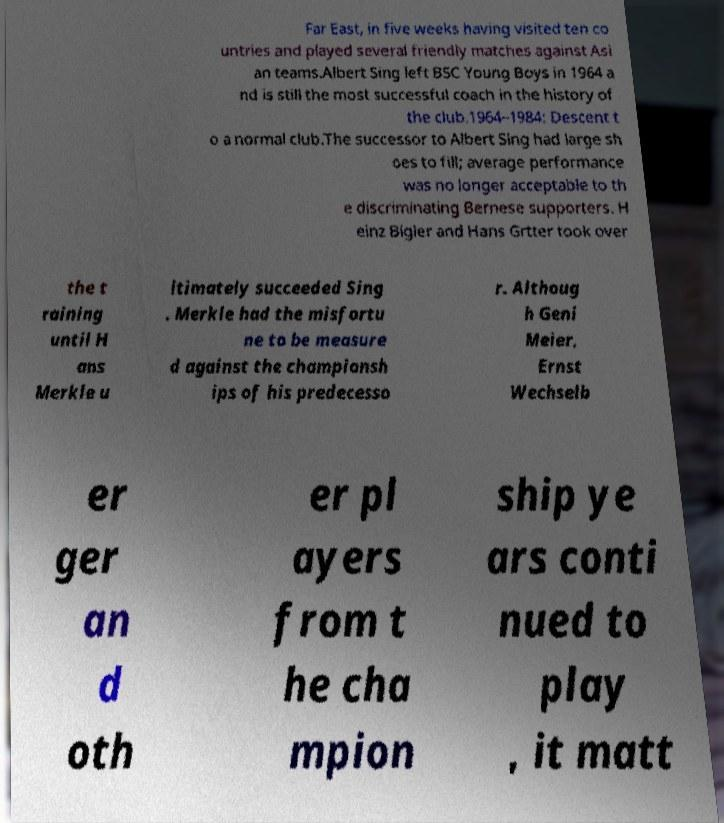What messages or text are displayed in this image? I need them in a readable, typed format. Far East, in five weeks having visited ten co untries and played several friendly matches against Asi an teams.Albert Sing left BSC Young Boys in 1964 a nd is still the most successful coach in the history of the club.1964–1984: Descent t o a normal club.The successor to Albert Sing had large sh oes to fill; average performance was no longer acceptable to th e discriminating Bernese supporters. H einz Bigler and Hans Grtter took over the t raining until H ans Merkle u ltimately succeeded Sing . Merkle had the misfortu ne to be measure d against the championsh ips of his predecesso r. Althoug h Geni Meier, Ernst Wechselb er ger an d oth er pl ayers from t he cha mpion ship ye ars conti nued to play , it matt 